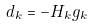<formula> <loc_0><loc_0><loc_500><loc_500>d _ { k } = - H _ { k } g _ { k }</formula> 